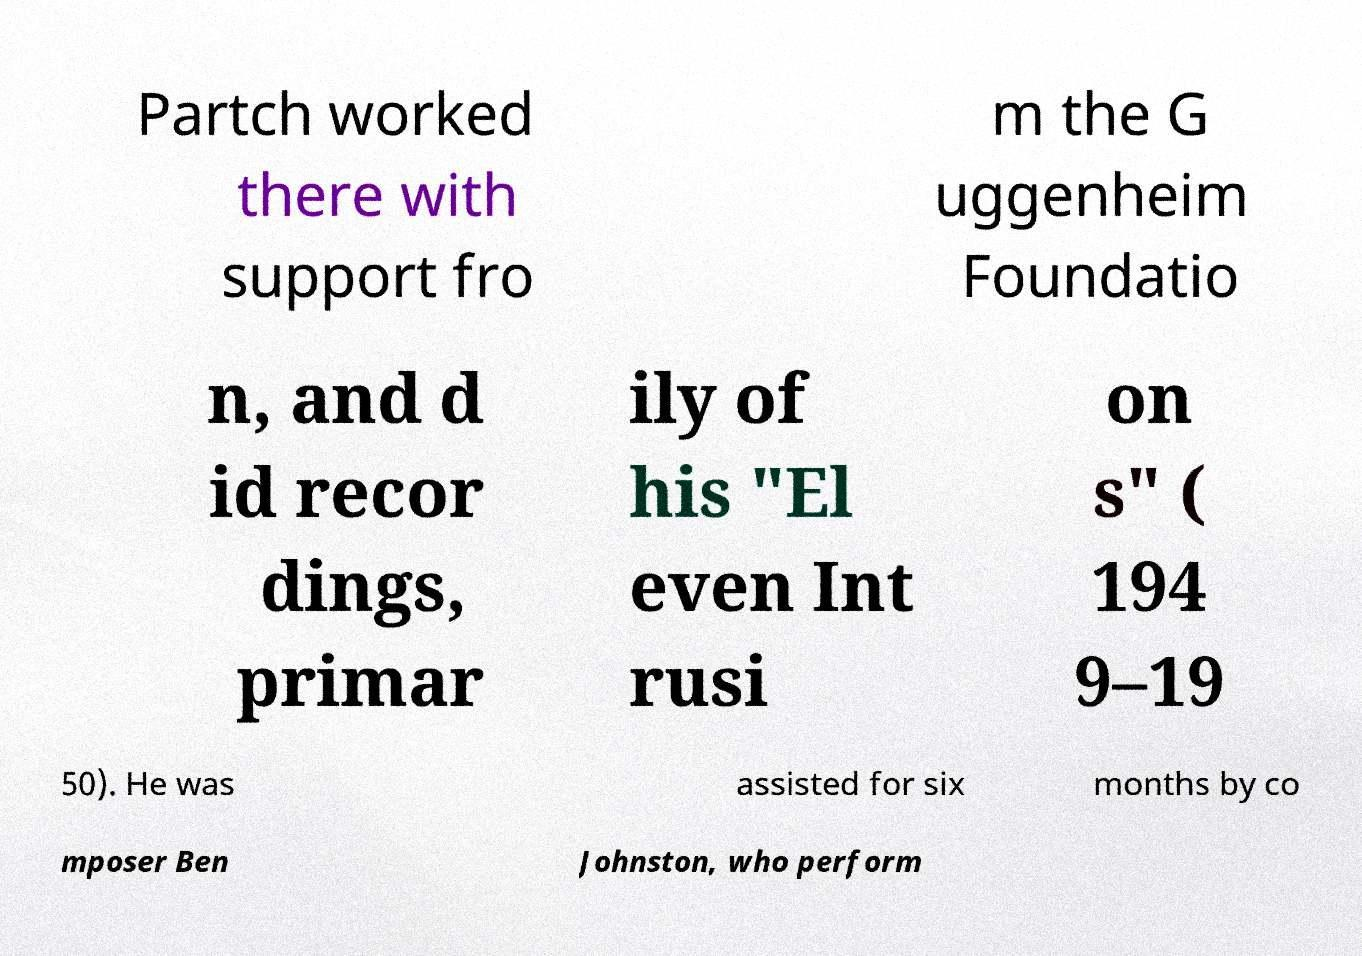There's text embedded in this image that I need extracted. Can you transcribe it verbatim? Partch worked there with support fro m the G uggenheim Foundatio n, and d id recor dings, primar ily of his "El even Int rusi on s" ( 194 9–19 50). He was assisted for six months by co mposer Ben Johnston, who perform 